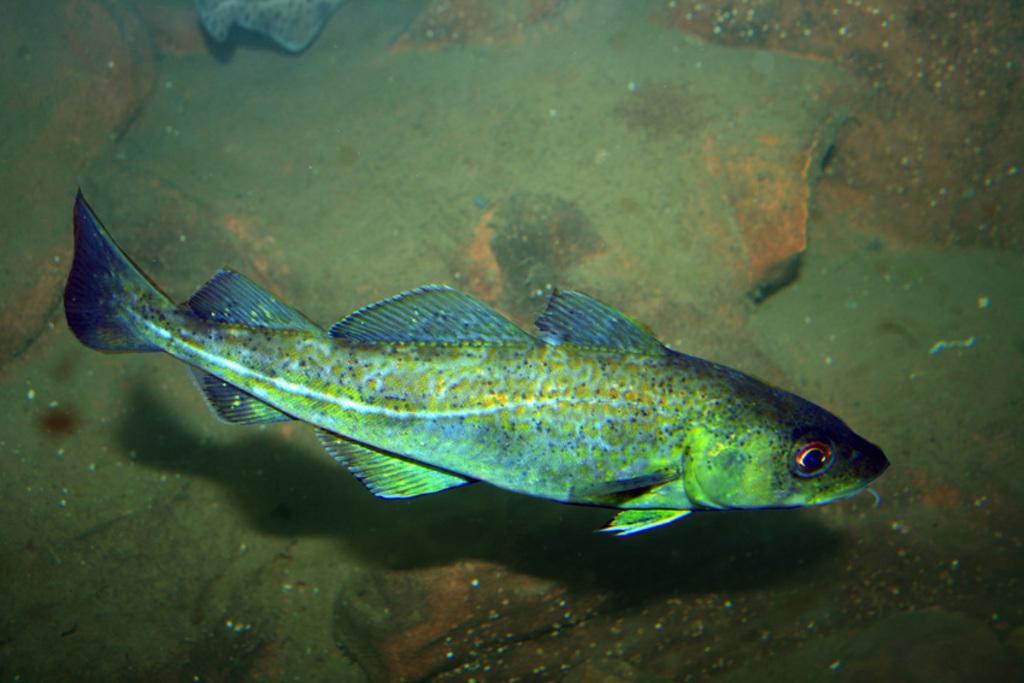Can you describe this image briefly? In this picture I can see a fish in the water and looks like a rock in the background. 